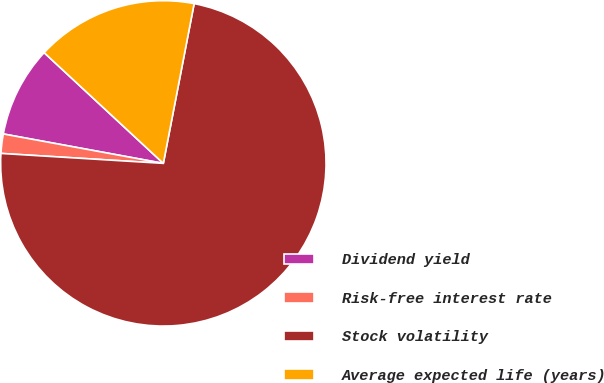Convert chart to OTSL. <chart><loc_0><loc_0><loc_500><loc_500><pie_chart><fcel>Dividend yield<fcel>Risk-free interest rate<fcel>Stock volatility<fcel>Average expected life (years)<nl><fcel>9.02%<fcel>1.92%<fcel>72.94%<fcel>16.12%<nl></chart> 